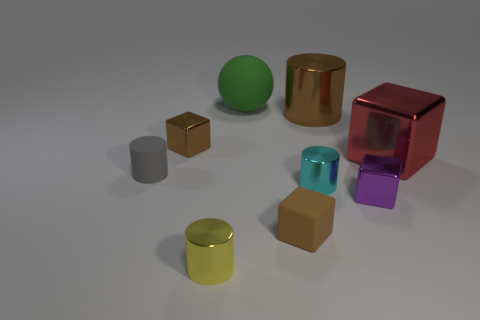What is the size of the shiny block that is the same color as the big cylinder?
Your response must be concise. Small. Do the brown thing in front of the cyan shiny cylinder and the metal object that is on the right side of the small purple shiny block have the same size?
Provide a short and direct response. No. What number of other things are there of the same size as the matte ball?
Make the answer very short. 2. Is there a red metallic block in front of the tiny rubber object that is to the left of the brown block that is on the left side of the green matte object?
Make the answer very short. No. Are there any other things that are the same color as the large metallic cube?
Offer a very short reply. No. How big is the cylinder behind the small rubber cylinder?
Your answer should be compact. Large. What size is the shiny cylinder that is behind the small block behind the small cube to the right of the big brown thing?
Offer a terse response. Large. What color is the matte thing that is behind the tiny rubber thing that is left of the yellow object?
Keep it short and to the point. Green. There is a tiny cyan thing that is the same shape as the large brown metal object; what is it made of?
Offer a terse response. Metal. Are there any other things that are the same material as the large cylinder?
Make the answer very short. Yes. 